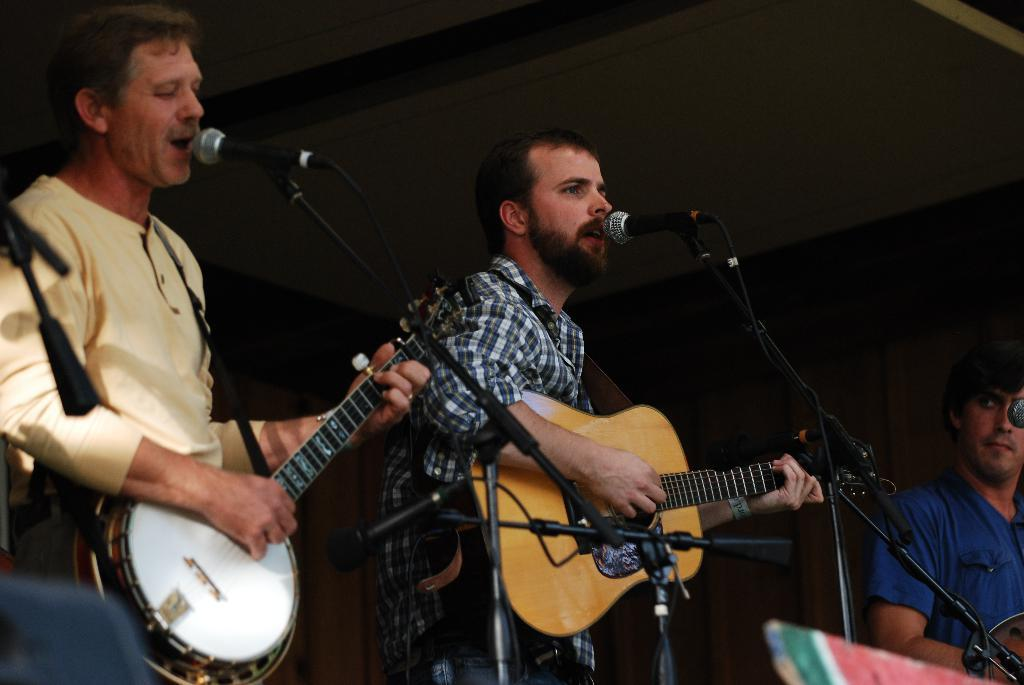How many people are in the image? There are three persons in the image. What are the persons doing in the image? The persons are standing and playing musical instruments. Can you describe the actions of one of the persons in the image? One person on the left side is singing a song. Where is the spot where the doll is sitting in the image? There is no doll present in the image, so there is no spot where a doll might be sitting. 